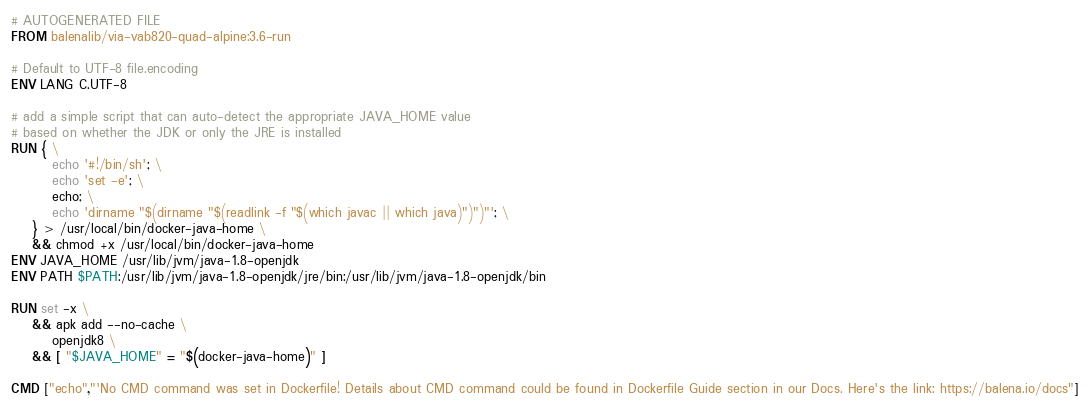<code> <loc_0><loc_0><loc_500><loc_500><_Dockerfile_># AUTOGENERATED FILE
FROM balenalib/via-vab820-quad-alpine:3.6-run

# Default to UTF-8 file.encoding
ENV LANG C.UTF-8

# add a simple script that can auto-detect the appropriate JAVA_HOME value
# based on whether the JDK or only the JRE is installed
RUN { \
		echo '#!/bin/sh'; \
		echo 'set -e'; \
		echo; \
		echo 'dirname "$(dirname "$(readlink -f "$(which javac || which java)")")"'; \
	} > /usr/local/bin/docker-java-home \
	&& chmod +x /usr/local/bin/docker-java-home
ENV JAVA_HOME /usr/lib/jvm/java-1.8-openjdk
ENV PATH $PATH:/usr/lib/jvm/java-1.8-openjdk/jre/bin:/usr/lib/jvm/java-1.8-openjdk/bin

RUN set -x \
	&& apk add --no-cache \
		openjdk8 \
	&& [ "$JAVA_HOME" = "$(docker-java-home)" ]

CMD ["echo","'No CMD command was set in Dockerfile! Details about CMD command could be found in Dockerfile Guide section in our Docs. Here's the link: https://balena.io/docs"]</code> 